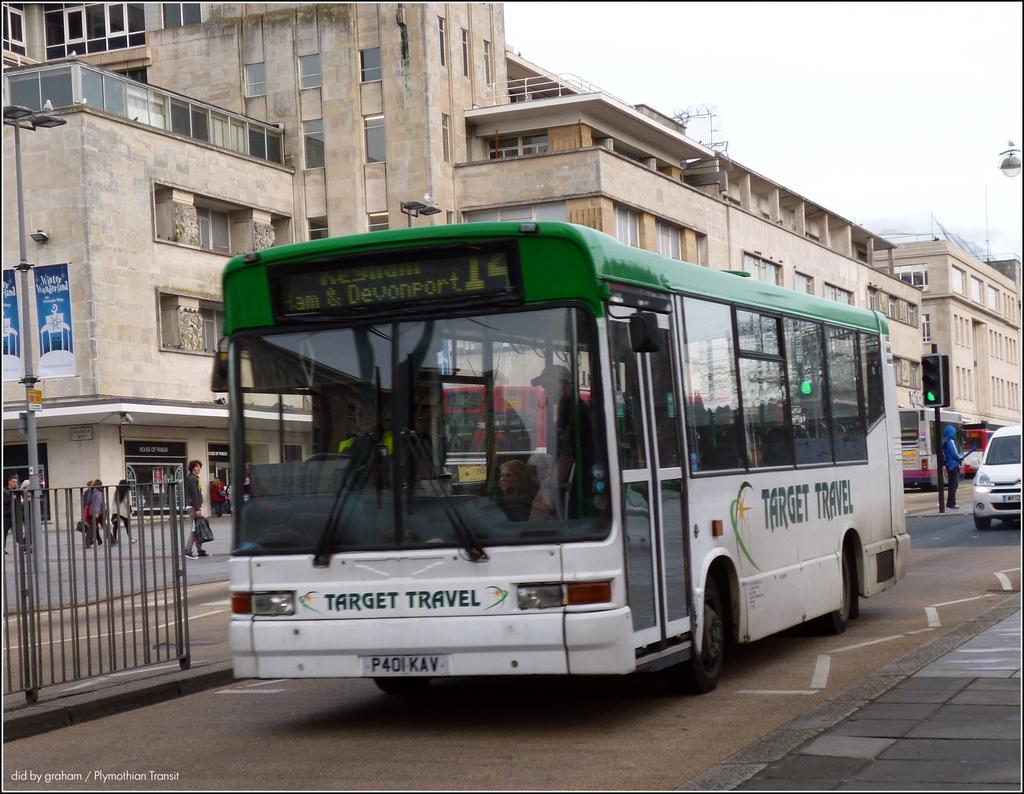Provide a one-sentence caption for the provided image. Target travel green and white bus is parked on a stree. 